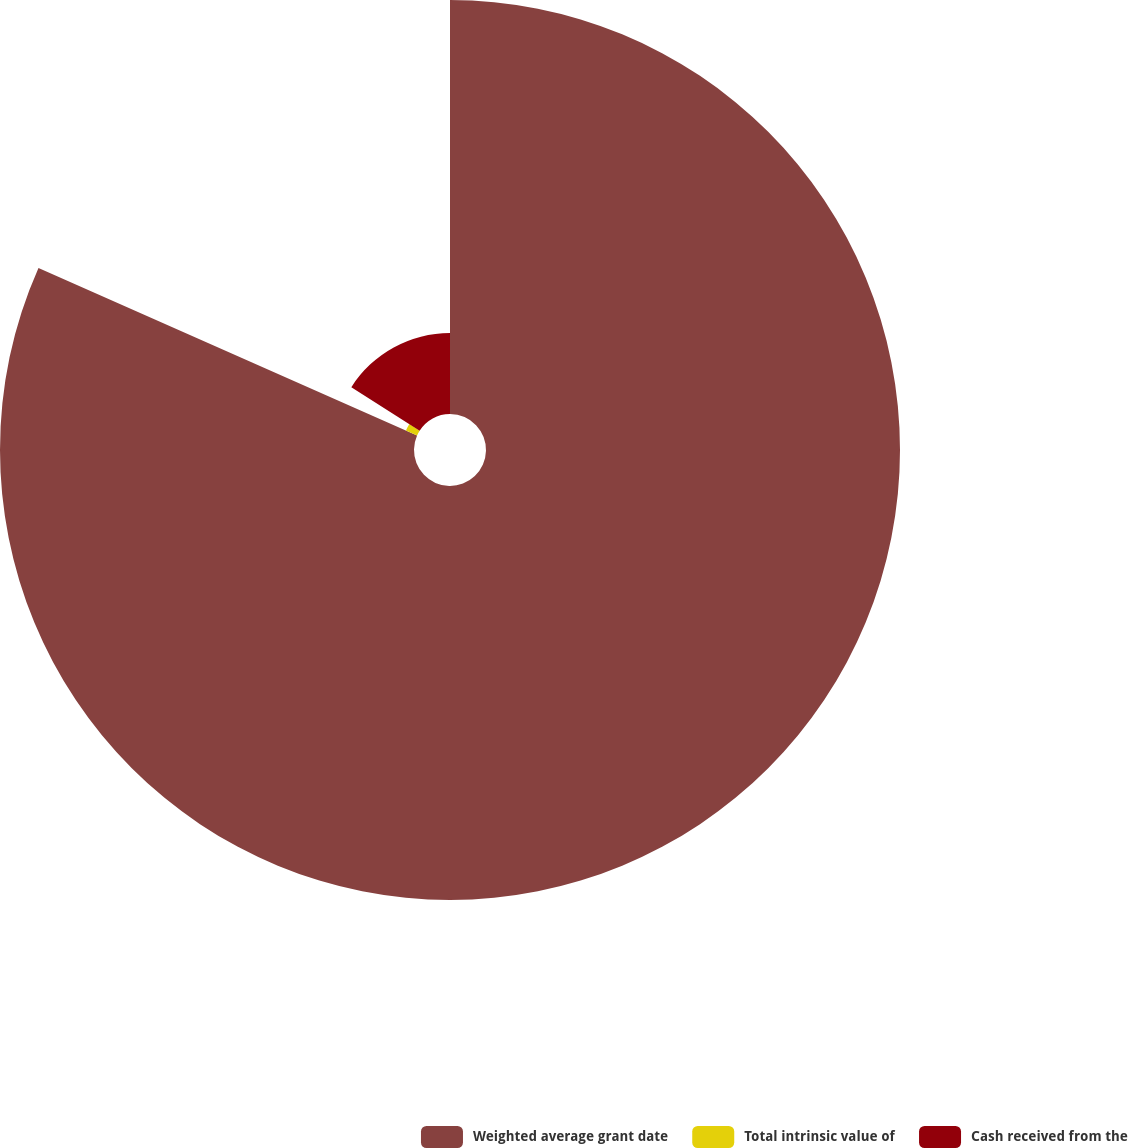Convert chart. <chart><loc_0><loc_0><loc_500><loc_500><pie_chart><fcel>Weighted average grant date<fcel>Total intrinsic value of<fcel>Cash received from the<nl><fcel>81.63%<fcel>2.4%<fcel>15.97%<nl></chart> 